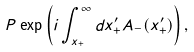Convert formula to latex. <formula><loc_0><loc_0><loc_500><loc_500>P \exp \left ( i \int _ { x _ { + } } ^ { \infty } d x _ { + } ^ { \prime } A _ { - } ( x _ { + } ^ { \prime } ) \right ) ,</formula> 